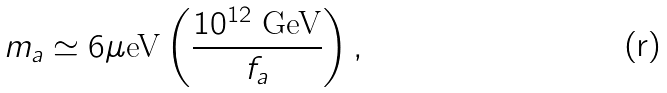Convert formula to latex. <formula><loc_0><loc_0><loc_500><loc_500>m _ { a } \simeq 6 \mu \text {eV} \left ( \frac { 1 0 ^ { 1 2 } \ \text {GeV} } { f _ { a } } \right ) ,</formula> 